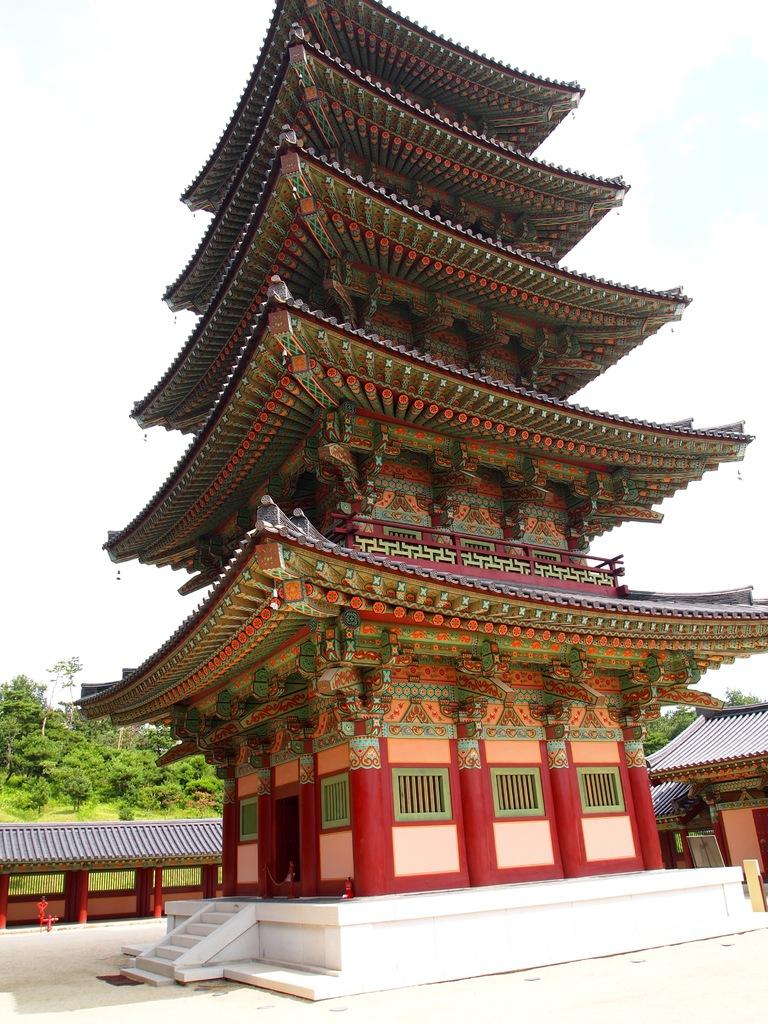What is the main subject in the center of the image? There is a house in the center of the image. What can be seen in the background of the image? There are houses and trees in the background of the image. What is visible at the top of the image? The sky is visible at the top of the image. What is located at the bottom of the image? There is a walkway at the bottom of the image. What is the title of the book that is being read by the tree in the image? There is no book or tree reading a book present in the image. 